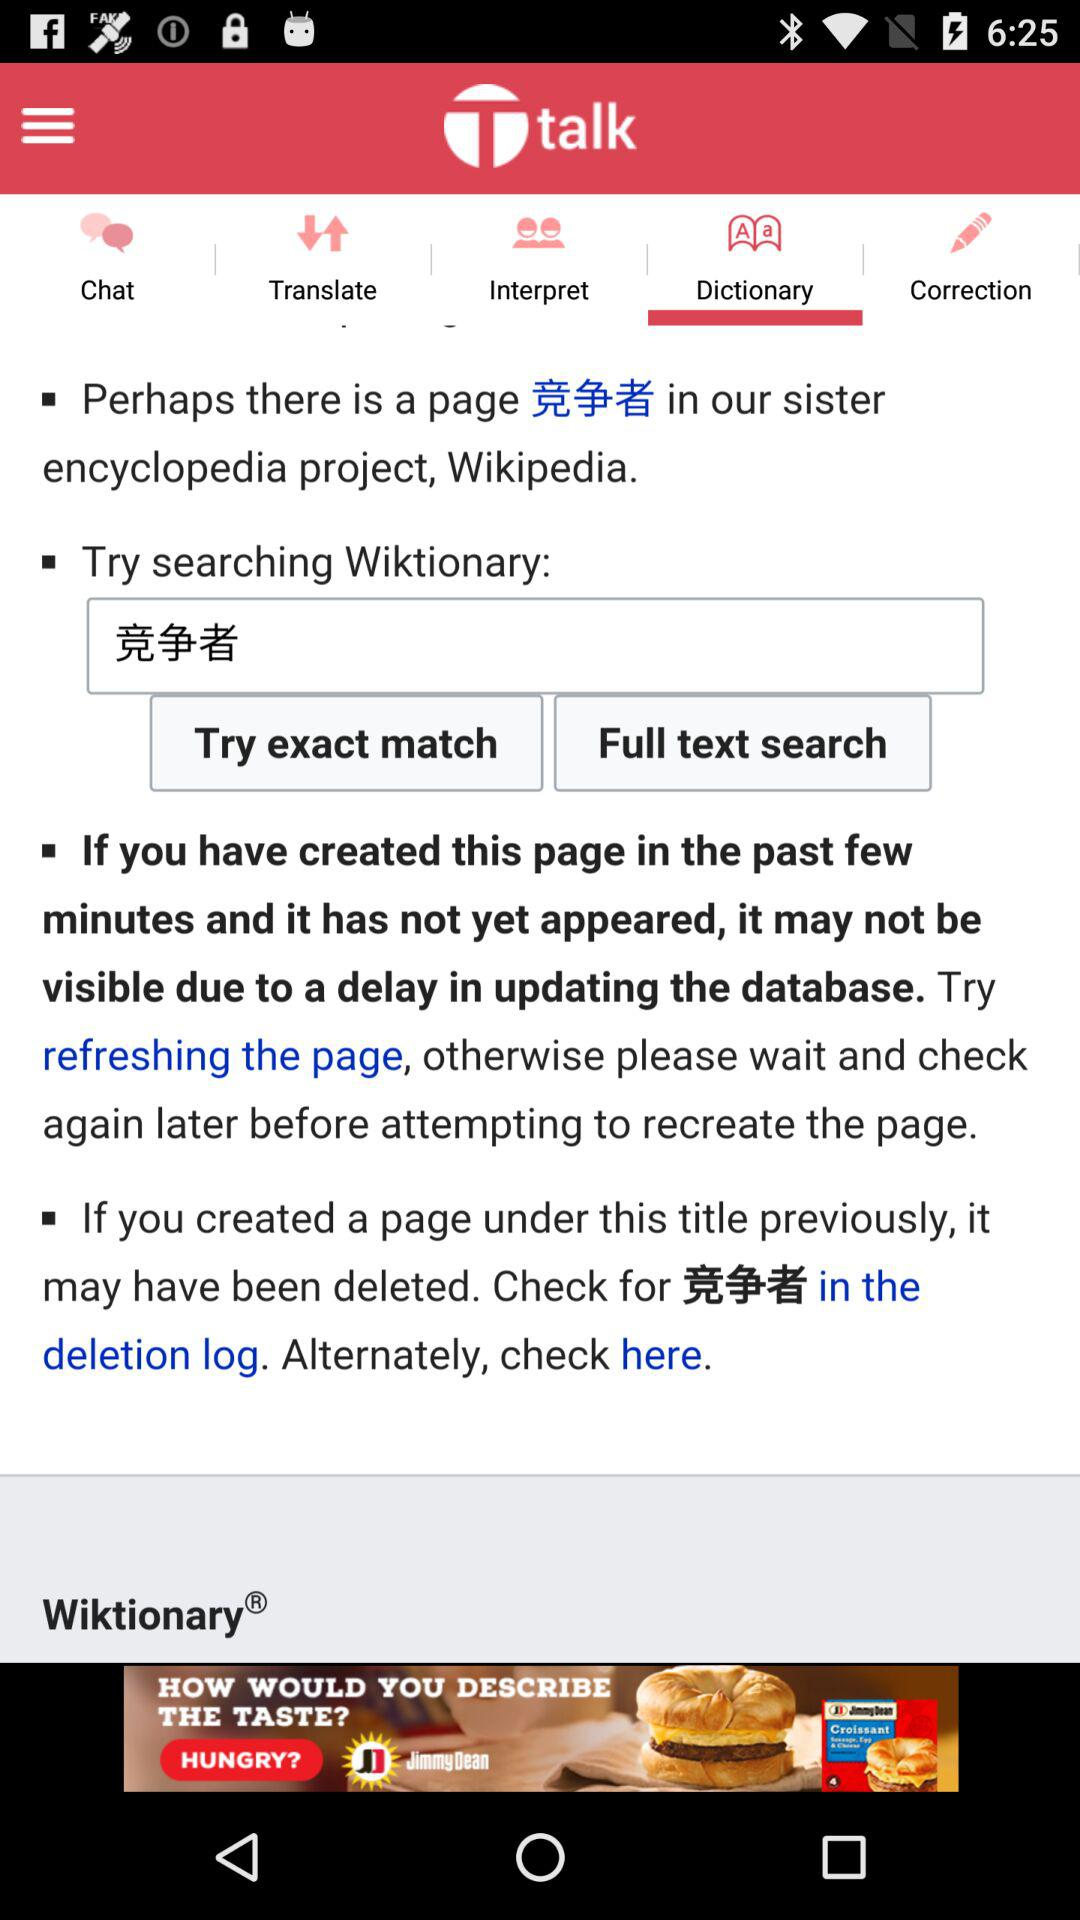How many text inputs are on the screen?
Answer the question using a single word or phrase. 1 